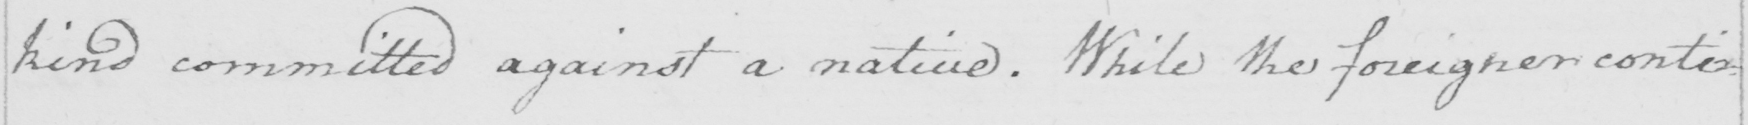What is written in this line of handwriting? kind committed against a native . While the foreigner conti= 